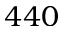Convert formula to latex. <formula><loc_0><loc_0><loc_500><loc_500>4 4 0</formula> 